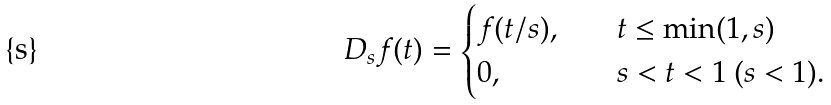Convert formula to latex. <formula><loc_0><loc_0><loc_500><loc_500>D _ { s } f ( t ) = \begin{cases} f ( t / s ) , \quad & t \leq \min ( 1 , s ) \\ 0 , \quad & s < t < 1 \ ( s < 1 ) . \end{cases}</formula> 